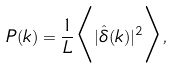<formula> <loc_0><loc_0><loc_500><loc_500>P ( k ) = \frac { 1 } { L } \Big < | \hat { \delta } ( k ) | ^ { 2 } \Big > ,</formula> 